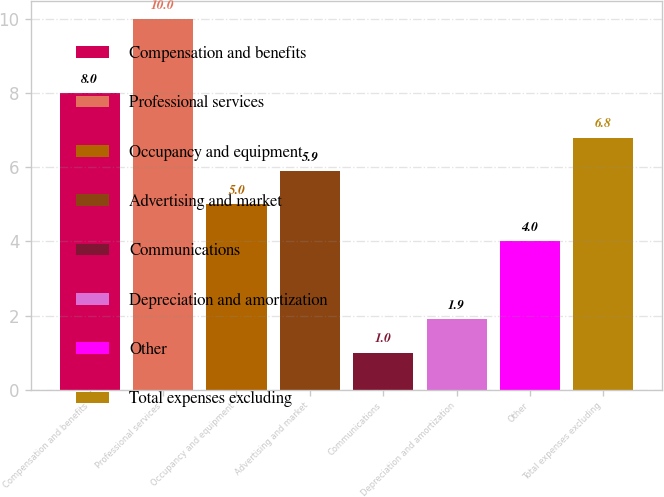<chart> <loc_0><loc_0><loc_500><loc_500><bar_chart><fcel>Compensation and benefits<fcel>Professional services<fcel>Occupancy and equipment<fcel>Advertising and market<fcel>Communications<fcel>Depreciation and amortization<fcel>Other<fcel>Total expenses excluding<nl><fcel>8<fcel>10<fcel>5<fcel>5.9<fcel>1<fcel>1.9<fcel>4<fcel>6.8<nl></chart> 